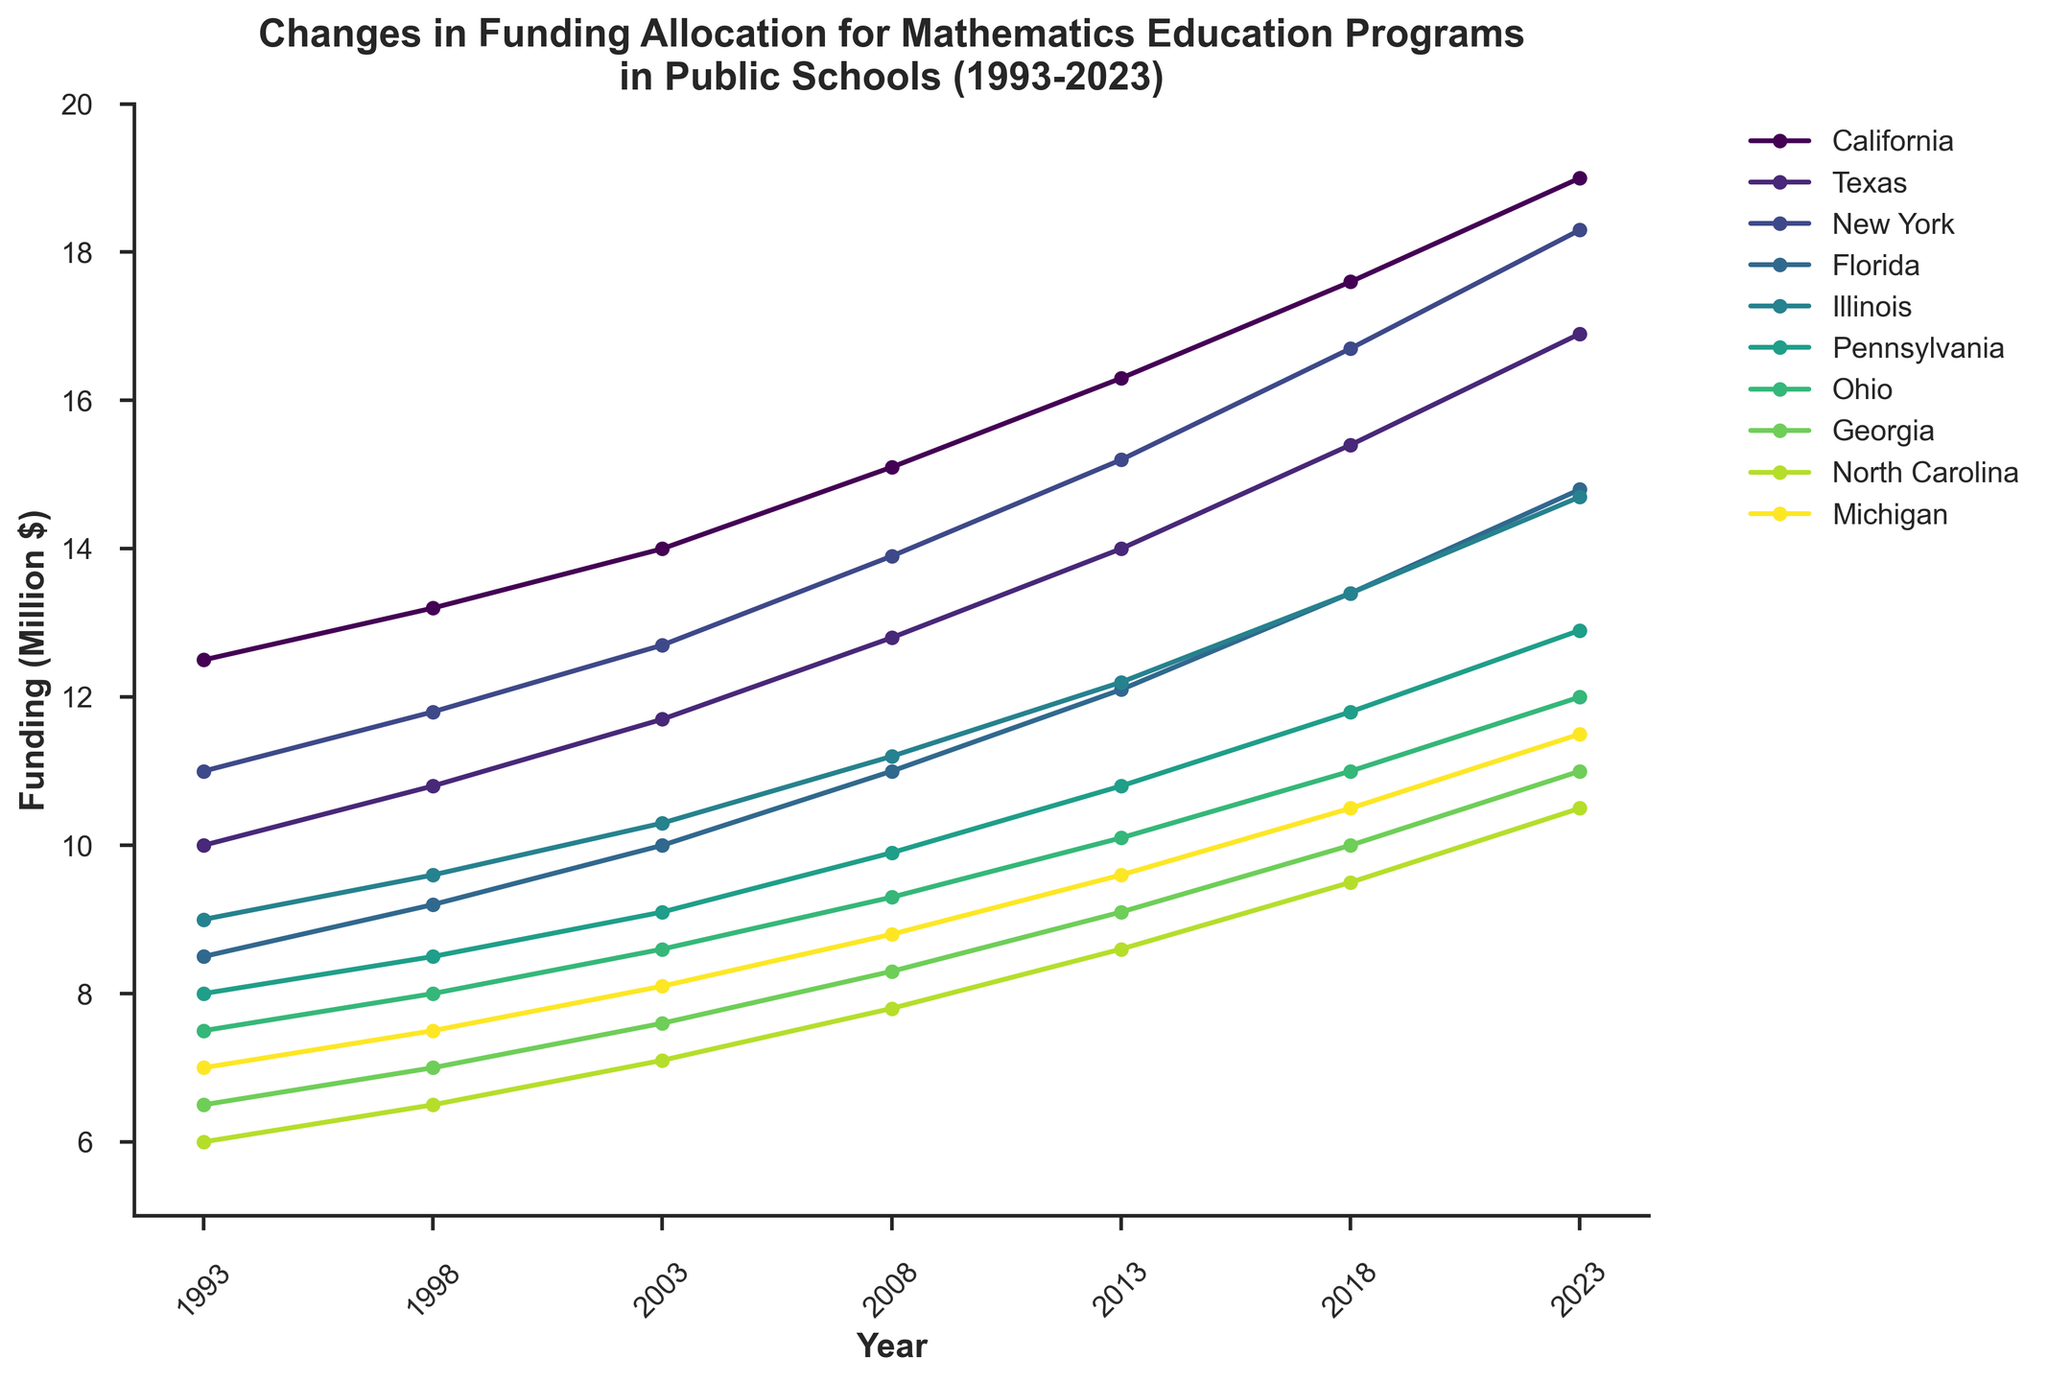Which state received the highest funding in 2023? Looking at the graph, the state with the highest funding in 2023 is the one reaching the highest point on the rightmost part of the plot. The plot shows California at the top rightmost position.
Answer: California How much did the funding for mathematics education in New York increase from 1993 to 2023? To find the increase, look at New York's funding in 1993 and subtract it from the funding in 2023. According to the graph, New York's funding in 1993 was $11 million and in 2023 it was $18.3 million. The increase is $18.3 million - $11 million = $7.3 million.
Answer: $7.3 million Which two states had the closest funding amounts in 2018? In 2018, observe the positions of the points on the plot that are closest to each other, vertically. Florida and Illinois have the most proximate values.
Answer: Florida and Illinois Calculate the average funding across all states in 2008. Add the funding amounts for all states in 2008 and divide by the number of states. The amounts are: 15.1, 12.8, 13.9, 11, 11.2, 9.9, 9.3, 8.3, 7.8, 8.8 (in millions). The total is 108.8 million, and there are 10 states, so the average is 108.8 / 10 = 10.88 million.
Answer: 10.88 million Is there any state that consistently had at least $10 million in funding every year from 1993 to 2023? Check each state's curve on the graph for each year between 1993 and 2023 to see if it never drops below the $10 million mark. California's curve always stays above $10 million throughout the period.
Answer: California Which state had the largest increase in funding from 1993 to 2023? To find the largest increase, compare the differences between the funding in 1993 and 2023 for each state. California increased from $12.5 million to $19 million which is an increase of $6.5 million, the largest among all states.
Answer: California By how much did the funding in Ohio change from 1998 to 2008? Examine Ohio's funding for both 1998 and 2008. The funding in 1998 was $8 million and in 2008 was $9.3 million. The change is $9.3 million - $8 million = $1.3 million.
Answer: $1.3 million Which state had the lowest funding in 2003? Observe the points on the plot for 2003 and identify the lowest one. In 2003, North Carolina has the lowest funding.
Answer: North Carolina Did any state's funding amount become exactly twice as much from 1993 to 2023? Compare each state's funding in 2023 to exactly twice their 1993 funding. None of the states meet this exact condition, as no state's 2023 value is double their 1993 value.
Answer: No What is the overall trend in funding for mathematics education across all states? Observe whether the lines for each state tend to go upwards, downwards, or stay the same over the years. The overall trend shows an upward slope for all states, indicating a general increase in funding over time.
Answer: Increase 